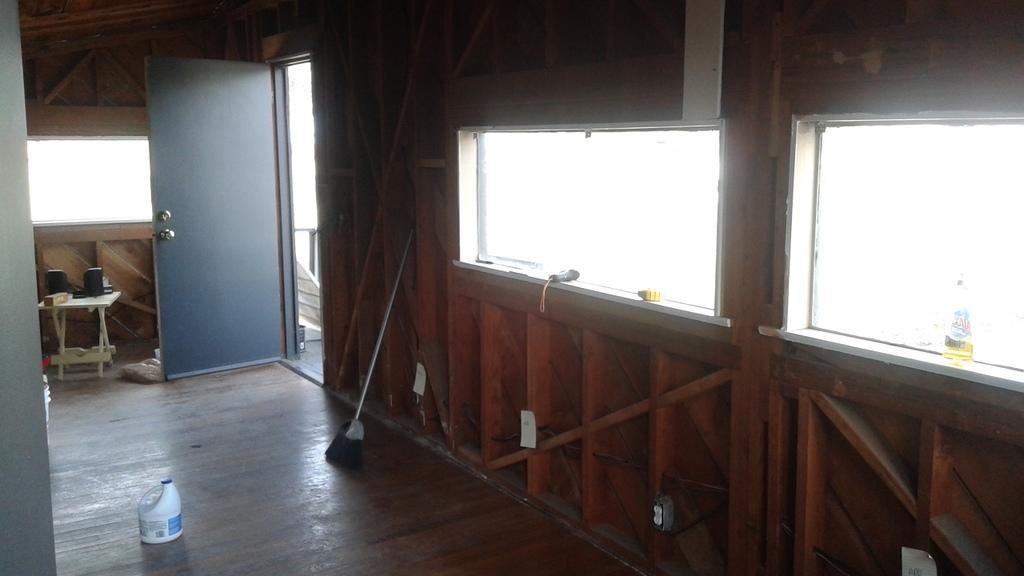How would you summarize this image in a sentence or two? This picture shows the inner view of a building. There are some objects in the windows, some objects on the table, one object on the left side of the image, three stickers attached to the wooden wall, some objects on the floor, three objects attached to the wooden wall and some objects on the ground near the door. 